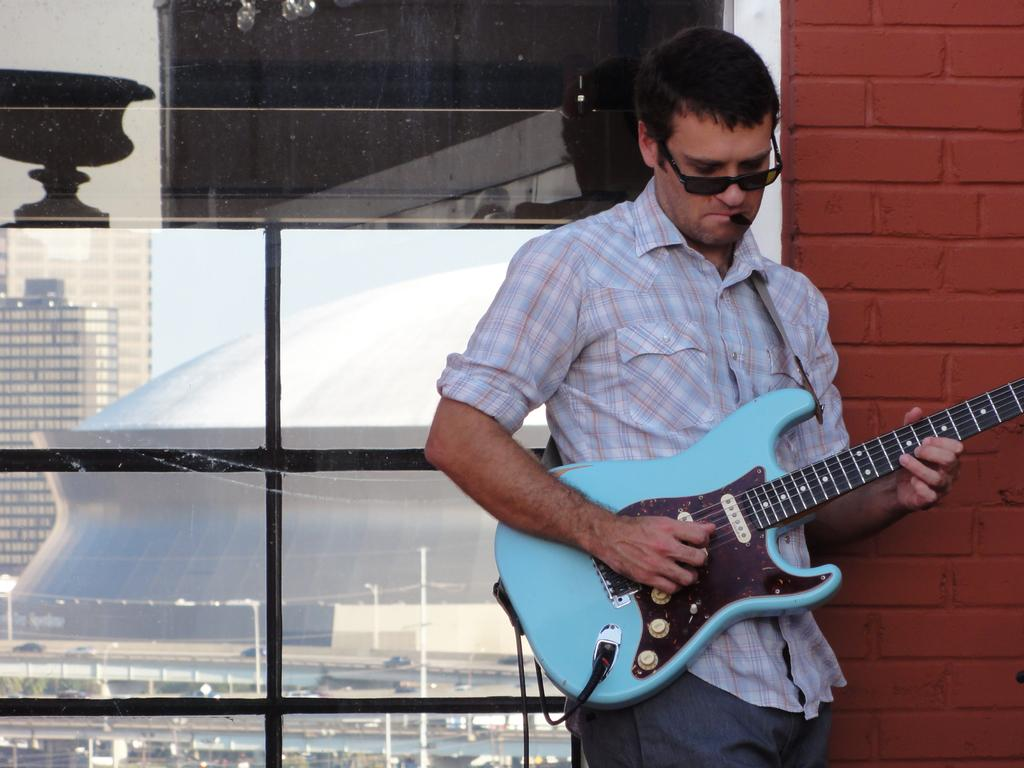What is the man doing on the right side of the image? The man is playing a guitar. What can be seen in the background of the image? There is a building, a glass object, and a brick wall in the background of the image. What type of pleasure can be seen in the harbor in the image? There is no harbor present in the image, so it is not possible to determine what type of pleasure might be seen there. 